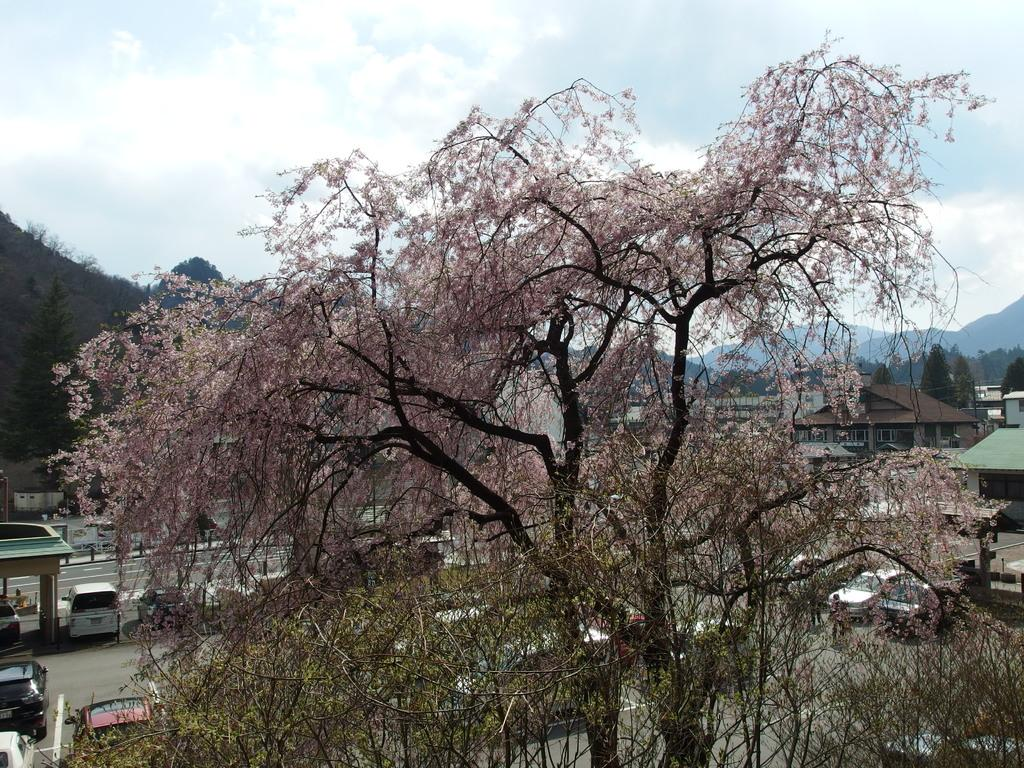What type of natural elements can be seen in the image? There are trees in the image. What type of man-made structures can be seen in the image? There are houses in the background of the image. What is happening on the road in the image? There are vehicles on the road in the image. What can be seen in the distance in the image? There are hills and clouds in the background of the image. What type of sweater is the person wearing in the image? There is no person wearing a sweater in the image. What is the name of the downtown area visible in the image? There is no downtown area visible in the image. 